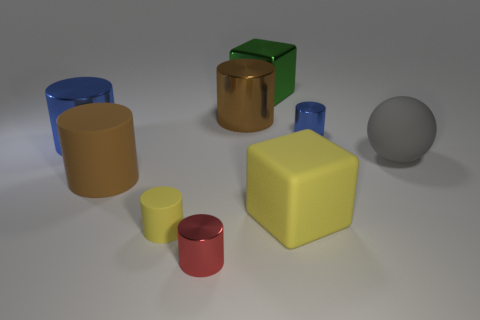There is a green thing that is the same material as the tiny red object; what is its shape?
Offer a very short reply. Cube. Are the small red cylinder and the yellow cube made of the same material?
Keep it short and to the point. No. Are there fewer big blue things that are right of the big blue object than brown cylinders behind the tiny blue object?
Your response must be concise. Yes. What size is the matte cylinder that is the same color as the rubber cube?
Give a very brief answer. Small. How many metal things are in front of the large brown cylinder that is in front of the blue metallic object to the left of the big green metal block?
Your answer should be compact. 1. Do the large rubber cylinder and the tiny rubber thing have the same color?
Your response must be concise. No. Are there any tiny cylinders of the same color as the small matte object?
Keep it short and to the point. No. What is the color of the sphere that is the same size as the yellow matte cube?
Offer a very short reply. Gray. Are there any large metal objects of the same shape as the small yellow object?
Your response must be concise. Yes. The metal object that is the same color as the big matte cylinder is what shape?
Your response must be concise. Cylinder. 